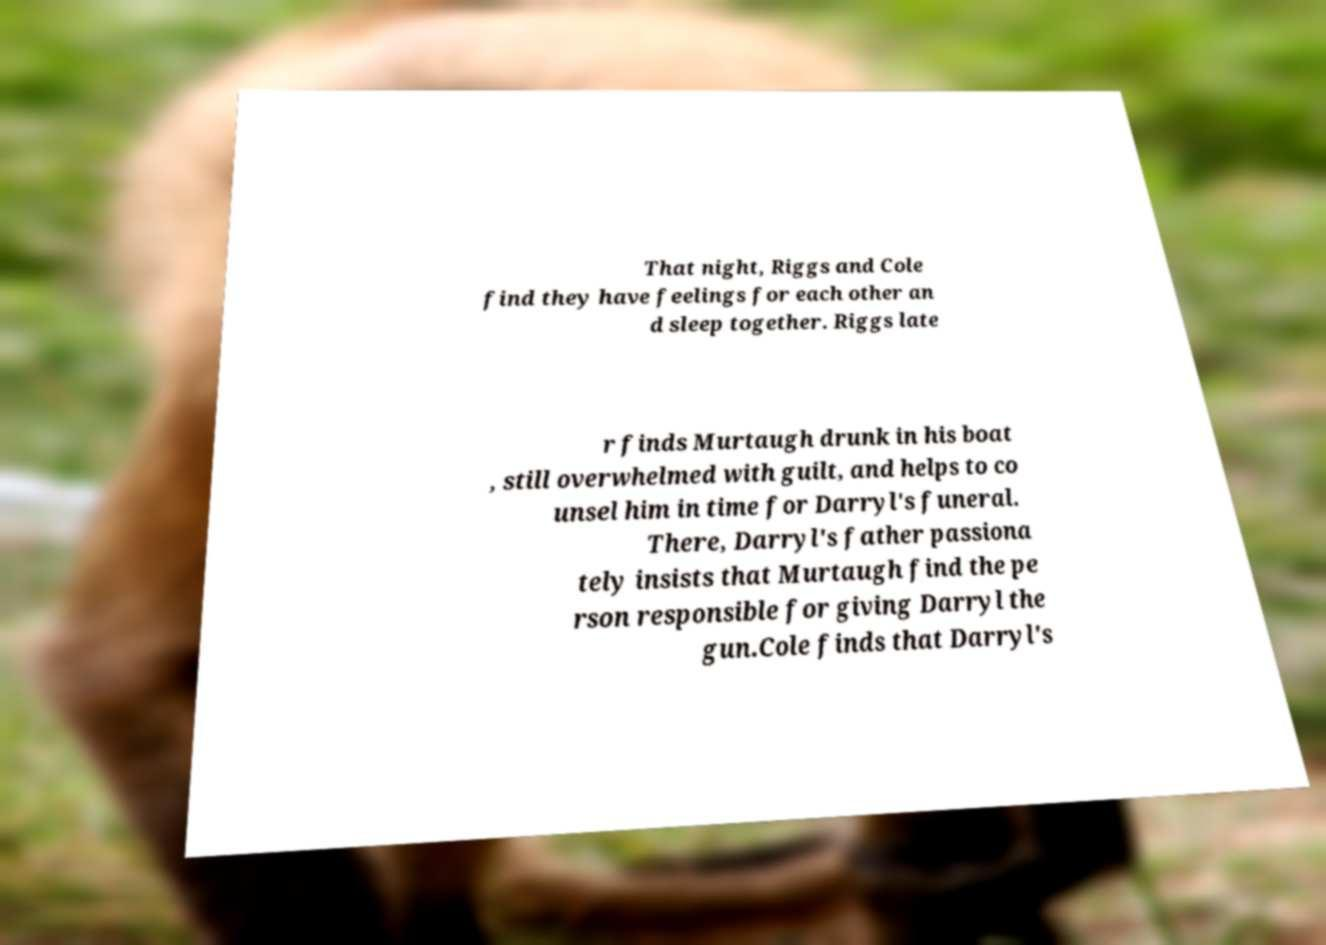Please identify and transcribe the text found in this image. That night, Riggs and Cole find they have feelings for each other an d sleep together. Riggs late r finds Murtaugh drunk in his boat , still overwhelmed with guilt, and helps to co unsel him in time for Darryl's funeral. There, Darryl's father passiona tely insists that Murtaugh find the pe rson responsible for giving Darryl the gun.Cole finds that Darryl's 